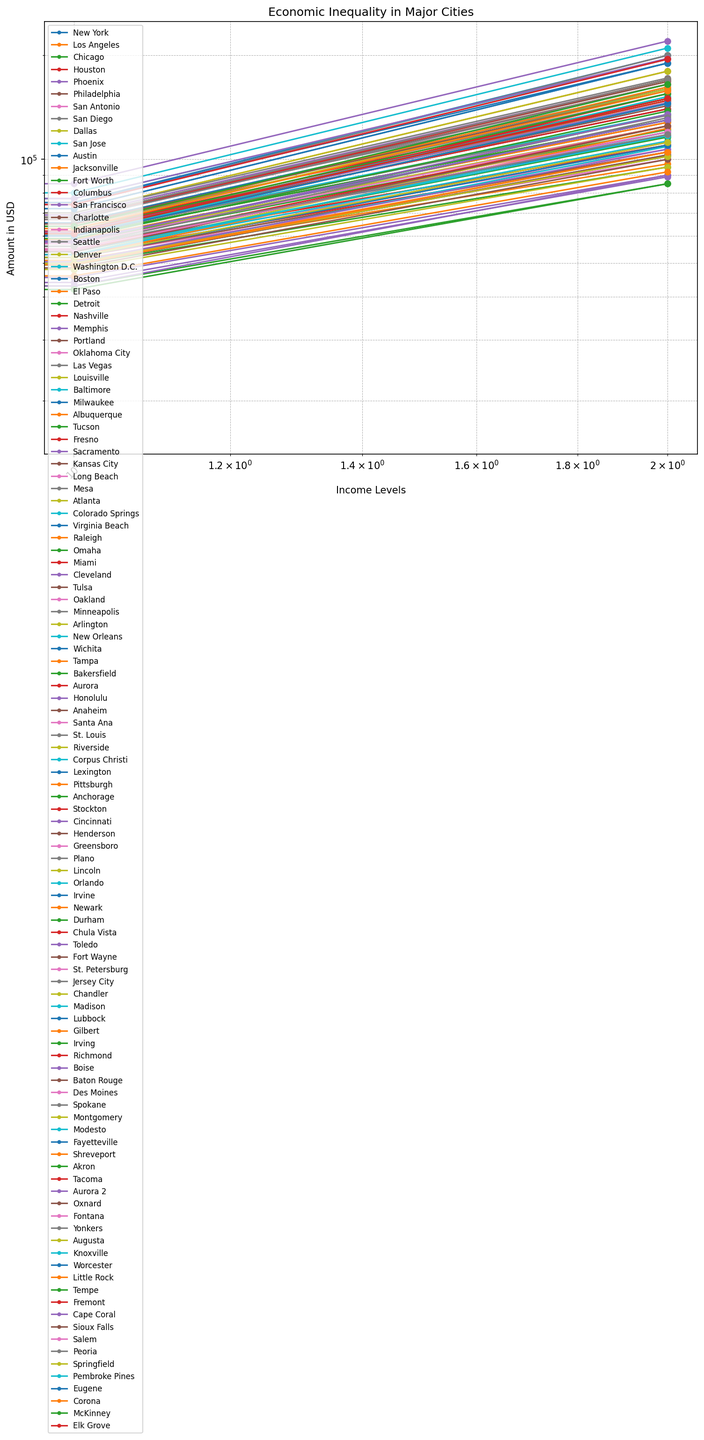Which city has the highest median housing price? Look at the visual representation of the data, and identify the city with the highest point on the median housing price axis.
Answer: San Francisco Comparing New York and Los Angeles, which city has a higher low-income value and by how much? Find the plot points of New York and Los Angeles for the low-income category, note their values, and subtract the value for Los Angeles from the value for New York.
Answer: New York, by $2,000 What is the trend of income levels in San Jose and how do they compare to the housing prices? Examine the plot of San Jose and observe how low, middle, and high-income values increase. Compare their trajectory with the single point denoting the median housing price.
Answer: Increasing income trend; median housing price significantly higher Which income level varies the most across all the cities? Assess the spread (range) of the data points for low, middle, and high-income levels across all cities to see which has the greatest difference between the highest and lowest values.
Answer: High Income For the city of Seattle, how does the high-income level compare to the median housing price? Locate the data points for Seattle’s high-income level and median housing price, and determine their relationship (order of magnitude, relative placement).
Answer: High income is significantly lower than the median housing price Is there any city where the low-income level is close to the median housing price? Look at the plots, focusing on the proximity of the low-income points to the median housing price points.
Answer: No What is the ratio of high income to low income in Chicago, and what does this indicate about economic inequality there? Locate Chicago’s high and low-income values, calculate the ratio high/low, and interpret the economic difference it reflects.
Answer: Ratio is approximately 6.54, indicating high inequality How does the middle-income level in Miami compare to its median housing price? Identify the middle-income value and median housing price for Miami and compare them by calculating the approximate magnitude differences.
Answer: Median housing price is significantly higher What is the combined total of low income and middle income for Cleveland? Find the low and middle-income values for Cleveland, add them together to find the total.
Answer: $59,000 Which city displays the smallest difference between low and high-income levels? Evaluate the gaps between low and high-income points for each city and identify the city with the smallest gap.
Answer: Detroit 